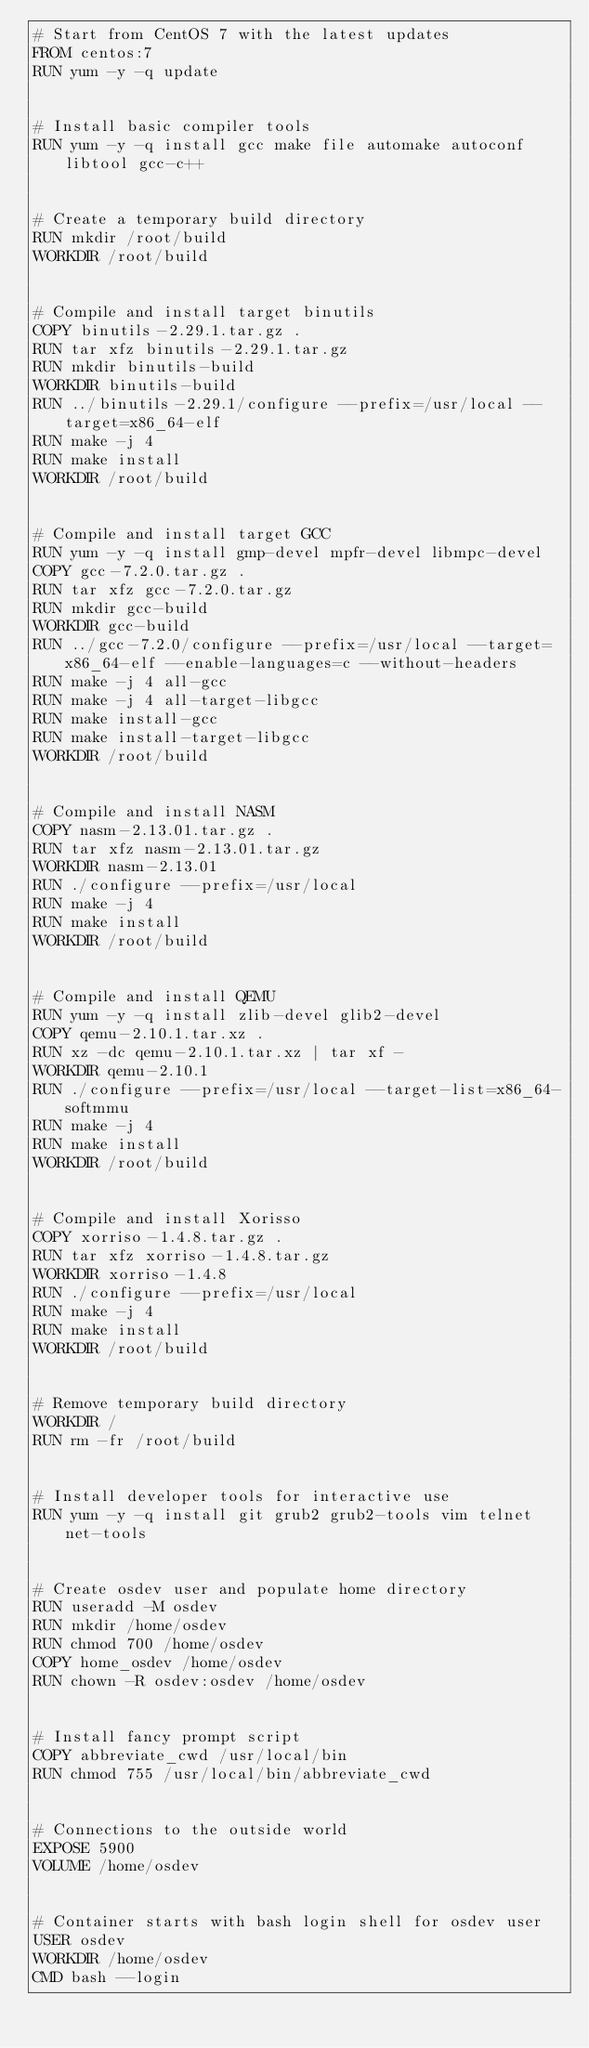Convert code to text. <code><loc_0><loc_0><loc_500><loc_500><_Dockerfile_># Start from CentOS 7 with the latest updates
FROM centos:7
RUN yum -y -q update


# Install basic compiler tools
RUN yum -y -q install gcc make file automake autoconf libtool gcc-c++


# Create a temporary build directory
RUN mkdir /root/build
WORKDIR /root/build


# Compile and install target binutils
COPY binutils-2.29.1.tar.gz .
RUN tar xfz binutils-2.29.1.tar.gz
RUN mkdir binutils-build
WORKDIR binutils-build
RUN ../binutils-2.29.1/configure --prefix=/usr/local --target=x86_64-elf
RUN make -j 4
RUN make install
WORKDIR /root/build


# Compile and install target GCC
RUN yum -y -q install gmp-devel mpfr-devel libmpc-devel
COPY gcc-7.2.0.tar.gz .
RUN tar xfz gcc-7.2.0.tar.gz
RUN mkdir gcc-build
WORKDIR gcc-build
RUN ../gcc-7.2.0/configure --prefix=/usr/local --target=x86_64-elf --enable-languages=c --without-headers
RUN make -j 4 all-gcc
RUN make -j 4 all-target-libgcc
RUN make install-gcc
RUN make install-target-libgcc
WORKDIR /root/build


# Compile and install NASM
COPY nasm-2.13.01.tar.gz .
RUN tar xfz nasm-2.13.01.tar.gz
WORKDIR nasm-2.13.01
RUN ./configure --prefix=/usr/local
RUN make -j 4
RUN make install
WORKDIR /root/build


# Compile and install QEMU
RUN yum -y -q install zlib-devel glib2-devel
COPY qemu-2.10.1.tar.xz .
RUN xz -dc qemu-2.10.1.tar.xz | tar xf -
WORKDIR qemu-2.10.1
RUN ./configure --prefix=/usr/local --target-list=x86_64-softmmu
RUN make -j 4
RUN make install
WORKDIR /root/build


# Compile and install Xorisso
COPY xorriso-1.4.8.tar.gz .
RUN tar xfz xorriso-1.4.8.tar.gz
WORKDIR xorriso-1.4.8
RUN ./configure --prefix=/usr/local
RUN make -j 4
RUN make install
WORKDIR /root/build


# Remove temporary build directory
WORKDIR /
RUN rm -fr /root/build


# Install developer tools for interactive use
RUN yum -y -q install git grub2 grub2-tools vim telnet net-tools


# Create osdev user and populate home directory
RUN useradd -M osdev
RUN mkdir /home/osdev
RUN chmod 700 /home/osdev
COPY home_osdev /home/osdev
RUN chown -R osdev:osdev /home/osdev


# Install fancy prompt script
COPY abbreviate_cwd /usr/local/bin
RUN chmod 755 /usr/local/bin/abbreviate_cwd


# Connections to the outside world
EXPOSE 5900
VOLUME /home/osdev


# Container starts with bash login shell for osdev user
USER osdev
WORKDIR /home/osdev
CMD bash --login
</code> 